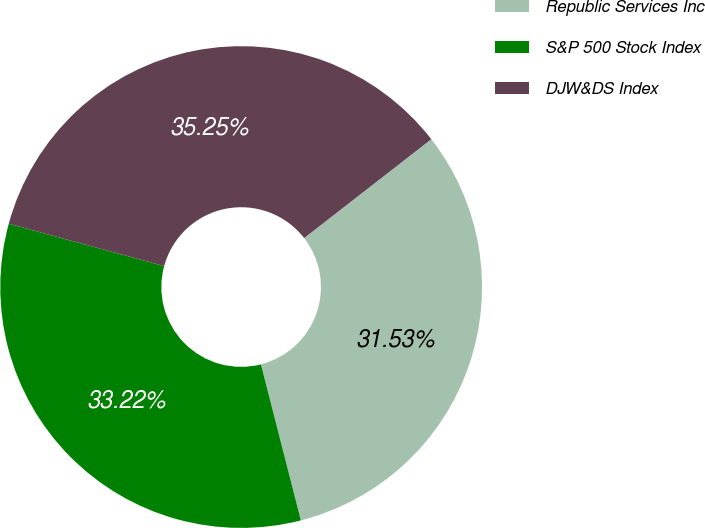<chart> <loc_0><loc_0><loc_500><loc_500><pie_chart><fcel>Republic Services Inc<fcel>S&P 500 Stock Index<fcel>DJW&DS Index<nl><fcel>31.53%<fcel>33.22%<fcel>35.25%<nl></chart> 